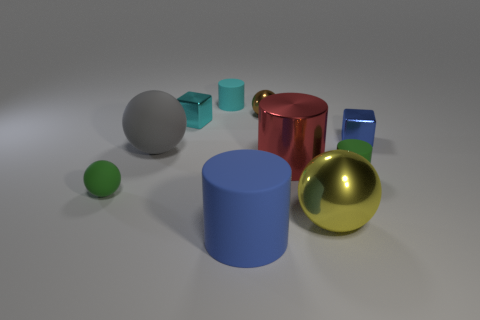Subtract all red metal cylinders. How many cylinders are left? 3 Subtract all cyan cubes. How many cubes are left? 1 Subtract 1 cubes. How many cubes are left? 1 Add 9 cyan shiny objects. How many cyan shiny objects exist? 10 Subtract 0 purple balls. How many objects are left? 10 Subtract all balls. How many objects are left? 6 Subtract all cyan blocks. Subtract all gray cylinders. How many blocks are left? 1 Subtract all small cyan rubber objects. Subtract all large metal things. How many objects are left? 7 Add 1 big matte spheres. How many big matte spheres are left? 2 